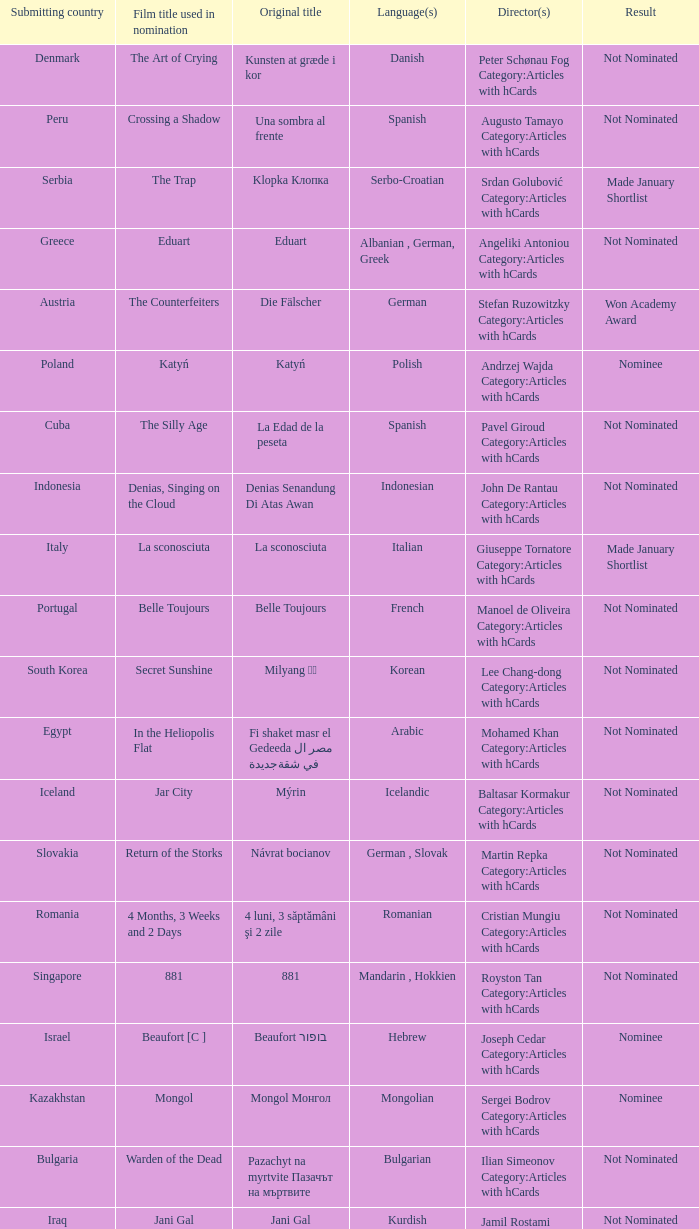What country submitted miehen työ? Finland. 